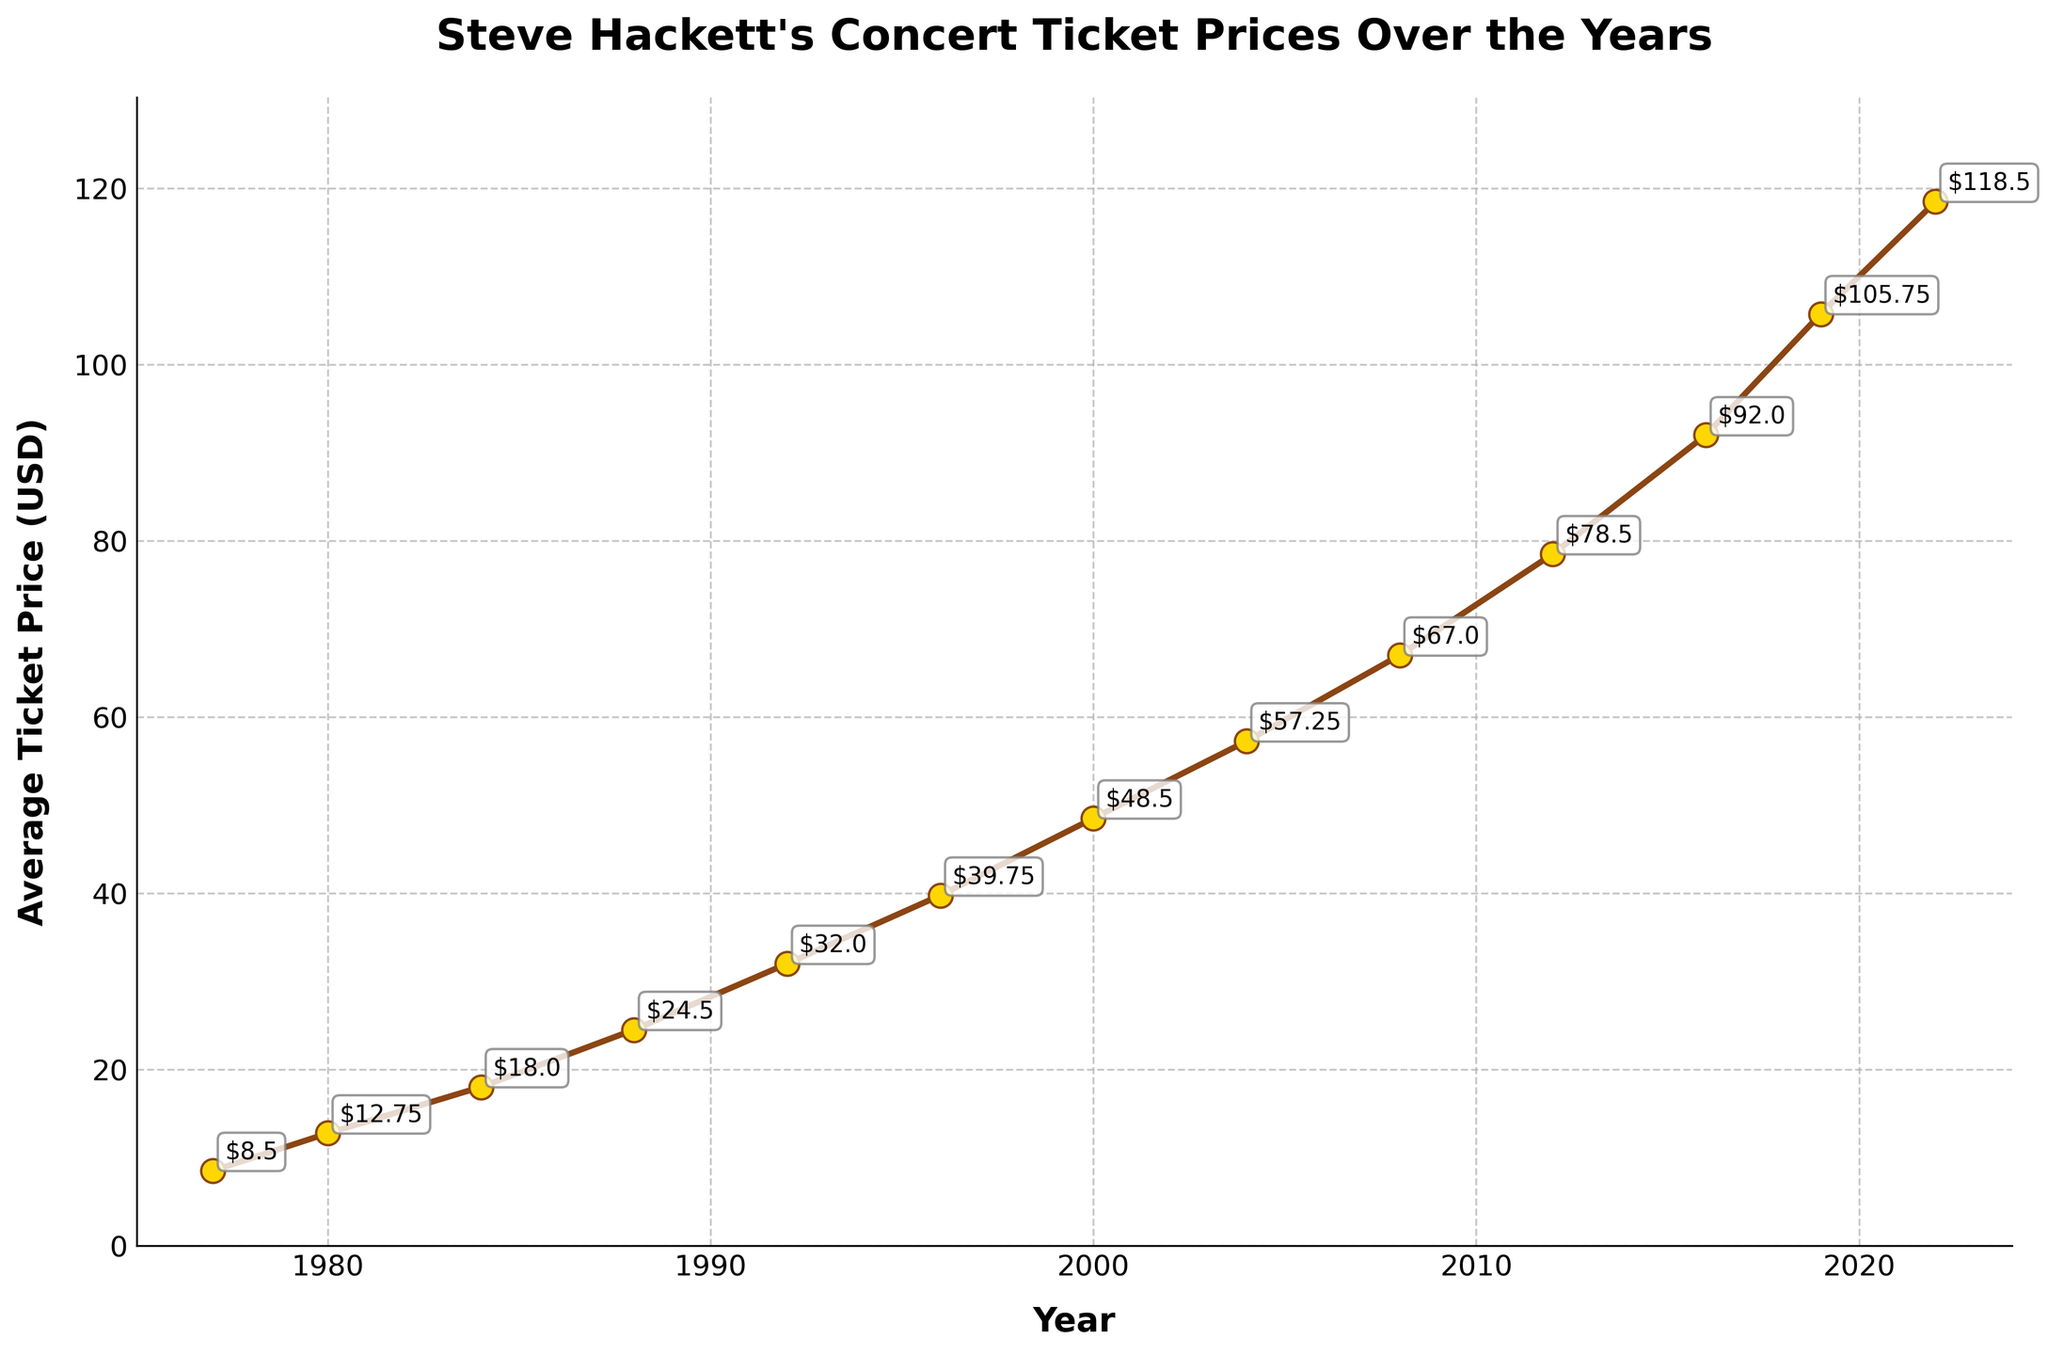What is the general trend of Steve Hackett's concert ticket prices from the 1970s to the present day? Observing the line chart, ticket prices have consistently increased over the years. Every few years, the prices rise, indicating an ongoing upward trend.
Answer: Upward trend How much did the average ticket price increase from 1977 to 2022? In 1977, the average ticket price was $8.50. By 2022, the price had risen to $118.50. The increase over this period can be calculated as $118.50 - $8.50 = $110.00.
Answer: $110.00 Which decade saw the largest increase in ticket prices? To determine this, analyze the differences in prices for each decade: 1977-1987 ($16), 1988-1998 ($15.25), 1996-2006 ($18.75), and so on. The largest increase is from 2012 to 2016, where the price difference is $13.50 ($92.00 - $78.50).
Answer: 2012 to 2016 By how much did ticket prices increase between 1980 and 2000? The price in 1980 was $12.75, and in 2000 it was $48.50. The increase is $48.50 - $12.75 = $35.75.
Answer: $35.75 Between which consecutive years did the smallest increase in ticket prices occur? By checking the differences between each pair of consecutive years, the smallest increase is between 1980 ($12.75) and 1984 ($18.00), with a difference of $5.25.
Answer: 1980 and 1984 What is the average ticket price for Steve Hackett's concerts across all the years listed? Sum all the ticket prices and divide by the number of years: ($8.50 + $12.75 + $18.00 + $24.50 + $32.00 + $39.75 + $48.50 + $57.25 + $67.00 + $78.50 + $92.00 + $105.75 + $118.50) / 13 = $54.96.
Answer: $54.96 How many times did the ticket price exceed $50? By counting the points on the graph where the price is above $50: 6 points (from 2000 onwards).
Answer: 6 times What was the ticket price in 2019, and how does it compare to the ticket price in 2000? In 2019, the ticket price was $105.75. In 2000, it was $48.50. Comparing these, the 2019 price is higher by $105.75 - $48.50 = $57.25.
Answer: $105.75; $57.25 higher What color are the markers indicating the data points on the graph? Observing the visual attributes in the figure, the markers are gold with a brown border.
Answer: Gold with brown border 